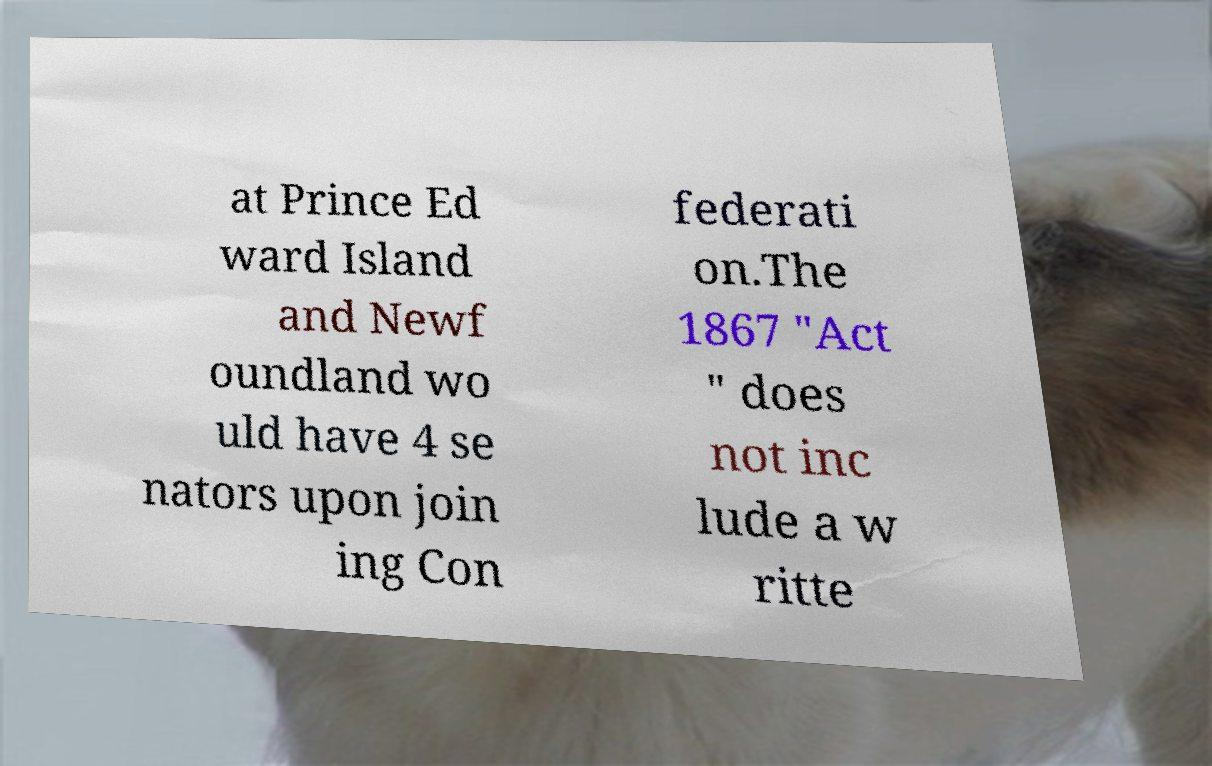Can you read and provide the text displayed in the image?This photo seems to have some interesting text. Can you extract and type it out for me? at Prince Ed ward Island and Newf oundland wo uld have 4 se nators upon join ing Con federati on.The 1867 "Act " does not inc lude a w ritte 